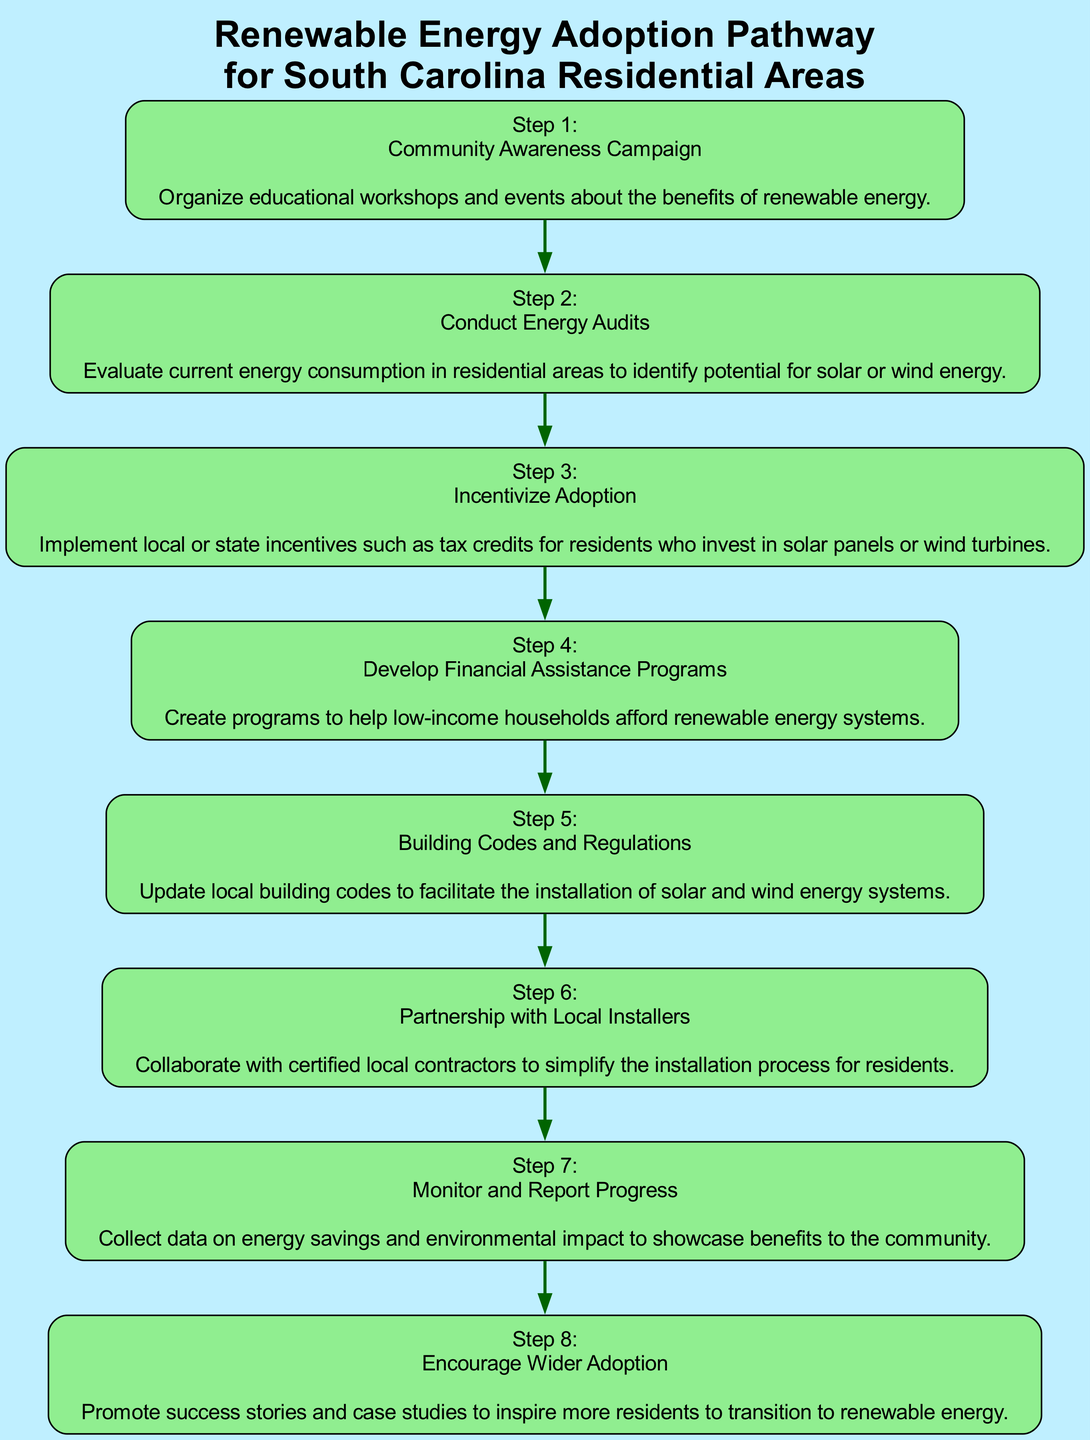What is the first step in the diagram? The first node listed in the diagram represents "Step 1," which is titled "Community Awareness Campaign." This indicates that it is the initial action to be taken in the pathway for renewable energy adoption.
Answer: Community Awareness Campaign How many total steps are there in the adoption pathway? By counting the elements in the diagram, it shows a total of 8 steps outlined in the flowchart, from Step 1 to Step 8.
Answer: 8 What is the last step displayed in the diagram? The last node indicates "Step 8," which is titled "Encourage Wider Adoption.” This is the final action to promote the adoption of renewable energy systems in the community.
Answer: Encourage Wider Adoption Which step involves financial help for low-income households? "Step 4" specifically addresses financial assistance programs aimed at helping low-income households afford renewable energy systems, indicating its focus on market accessibility.
Answer: Develop Financial Assistance Programs What follows after conducting energy audits? According to the flowchart, after "Step 2," which is "Conduct Energy Audits," the next action to be taken is "Step 3," "Incentivize Adoption," which encourages investment in renewable energy options.
Answer: Incentivize Adoption Which step emphasizes monitoring and reporting progress? In the diagram, "Step 7" emphasizes the action of monitoring and reporting progress on energy savings and environmental impacts, making it a critical part of the evaluation process.
Answer: Monitor and Report Progress What type of collaboration is mentioned in the steps? "Step 6" mentions a "Partnership with Local Installers," indicating a collaboration with certified local contractors aimed at simplifying the installation for residents.
Answer: Partnership with Local Installers Which steps are directly involved in promoting the benefits of renewable energy? Steps 1 ("Community Awareness Campaign") and 8 ("Encourage Wider Adoption") are involved in promoting the benefits; the first focuses on education and the last on inspiring others through success stories.
Answer: Community Awareness Campaign, Encourage Wider Adoption 